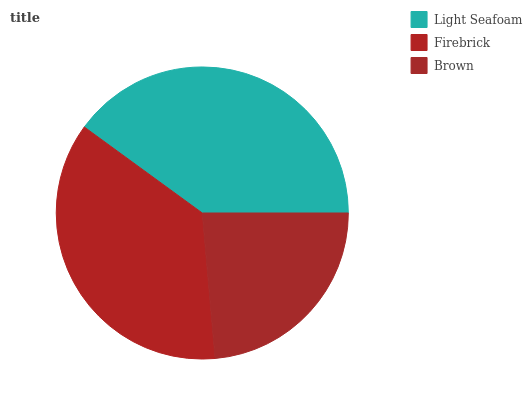Is Brown the minimum?
Answer yes or no. Yes. Is Light Seafoam the maximum?
Answer yes or no. Yes. Is Firebrick the minimum?
Answer yes or no. No. Is Firebrick the maximum?
Answer yes or no. No. Is Light Seafoam greater than Firebrick?
Answer yes or no. Yes. Is Firebrick less than Light Seafoam?
Answer yes or no. Yes. Is Firebrick greater than Light Seafoam?
Answer yes or no. No. Is Light Seafoam less than Firebrick?
Answer yes or no. No. Is Firebrick the high median?
Answer yes or no. Yes. Is Firebrick the low median?
Answer yes or no. Yes. Is Brown the high median?
Answer yes or no. No. Is Light Seafoam the low median?
Answer yes or no. No. 